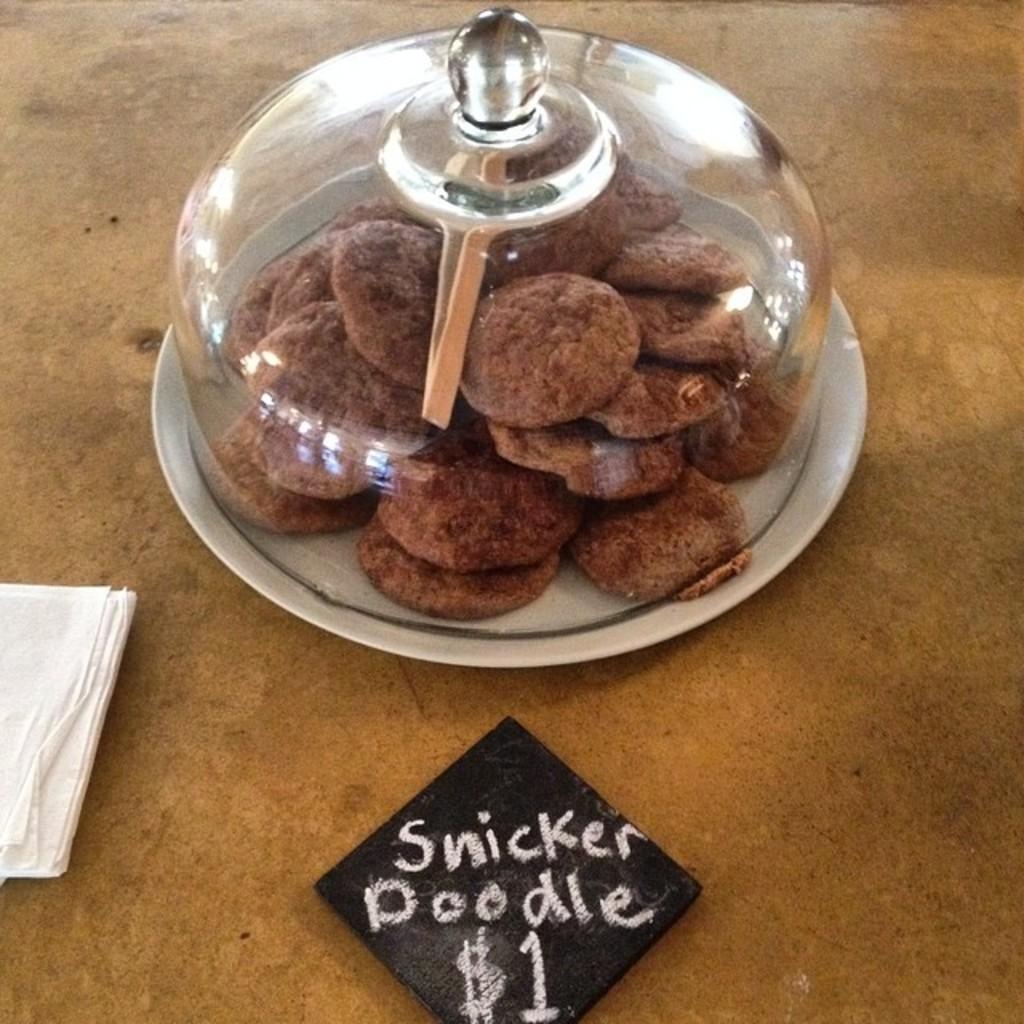Describe this image in one or two sentences. In this picture there are biscuits in a container, which is placed in the center of the image and there are tissues on the left side of the image, there is a name card at the bottom side of the image, on which it is written as snickerdoodles. 